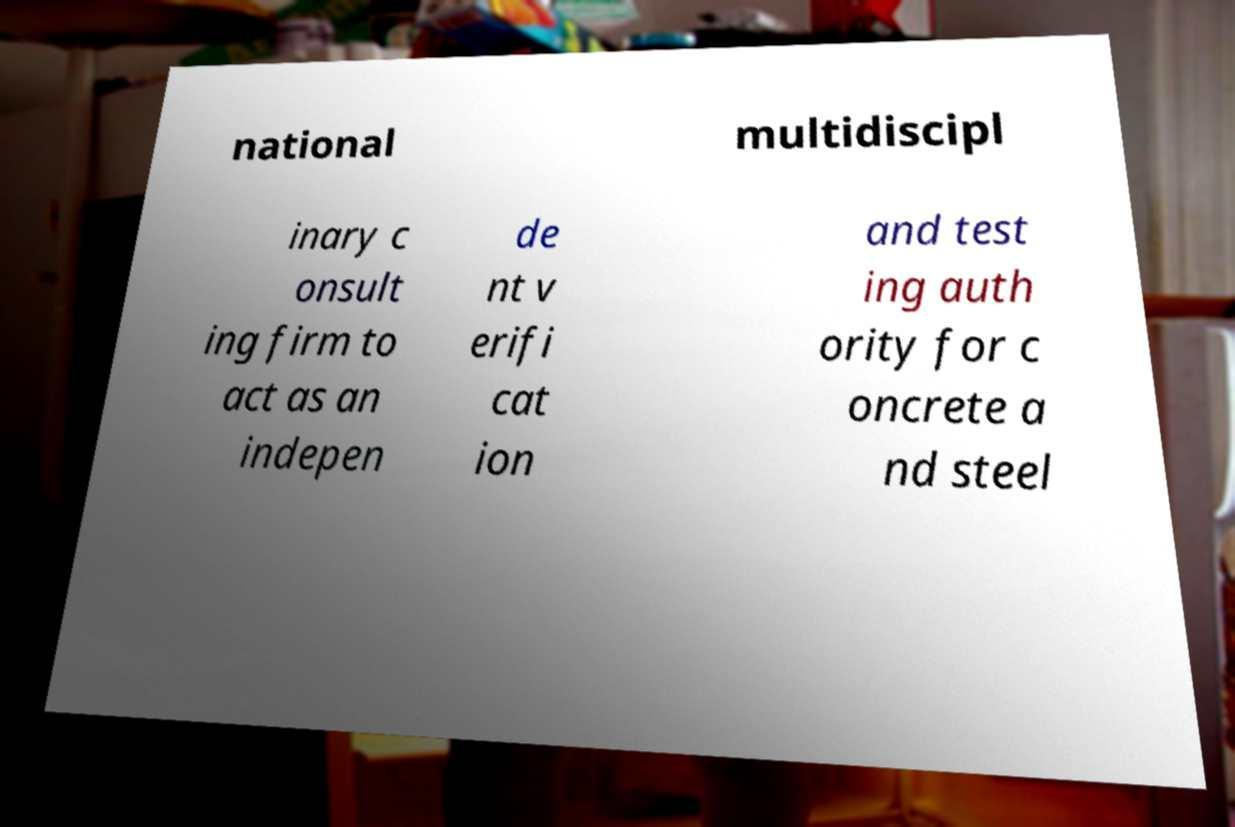For documentation purposes, I need the text within this image transcribed. Could you provide that? national multidiscipl inary c onsult ing firm to act as an indepen de nt v erifi cat ion and test ing auth ority for c oncrete a nd steel 